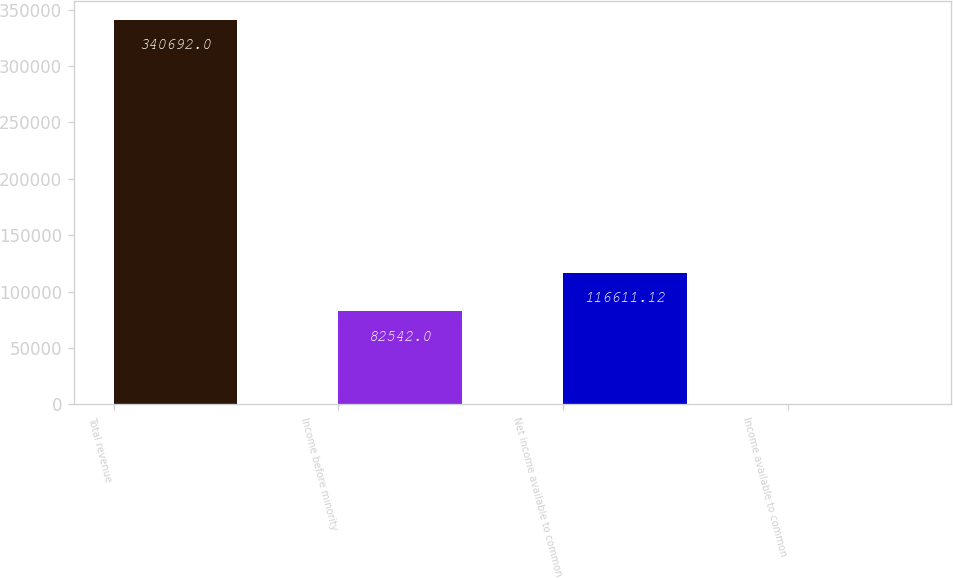<chart> <loc_0><loc_0><loc_500><loc_500><bar_chart><fcel>Total revenue<fcel>Income before minority<fcel>Net income available to common<fcel>Income available to common<nl><fcel>340692<fcel>82542<fcel>116611<fcel>0.79<nl></chart> 